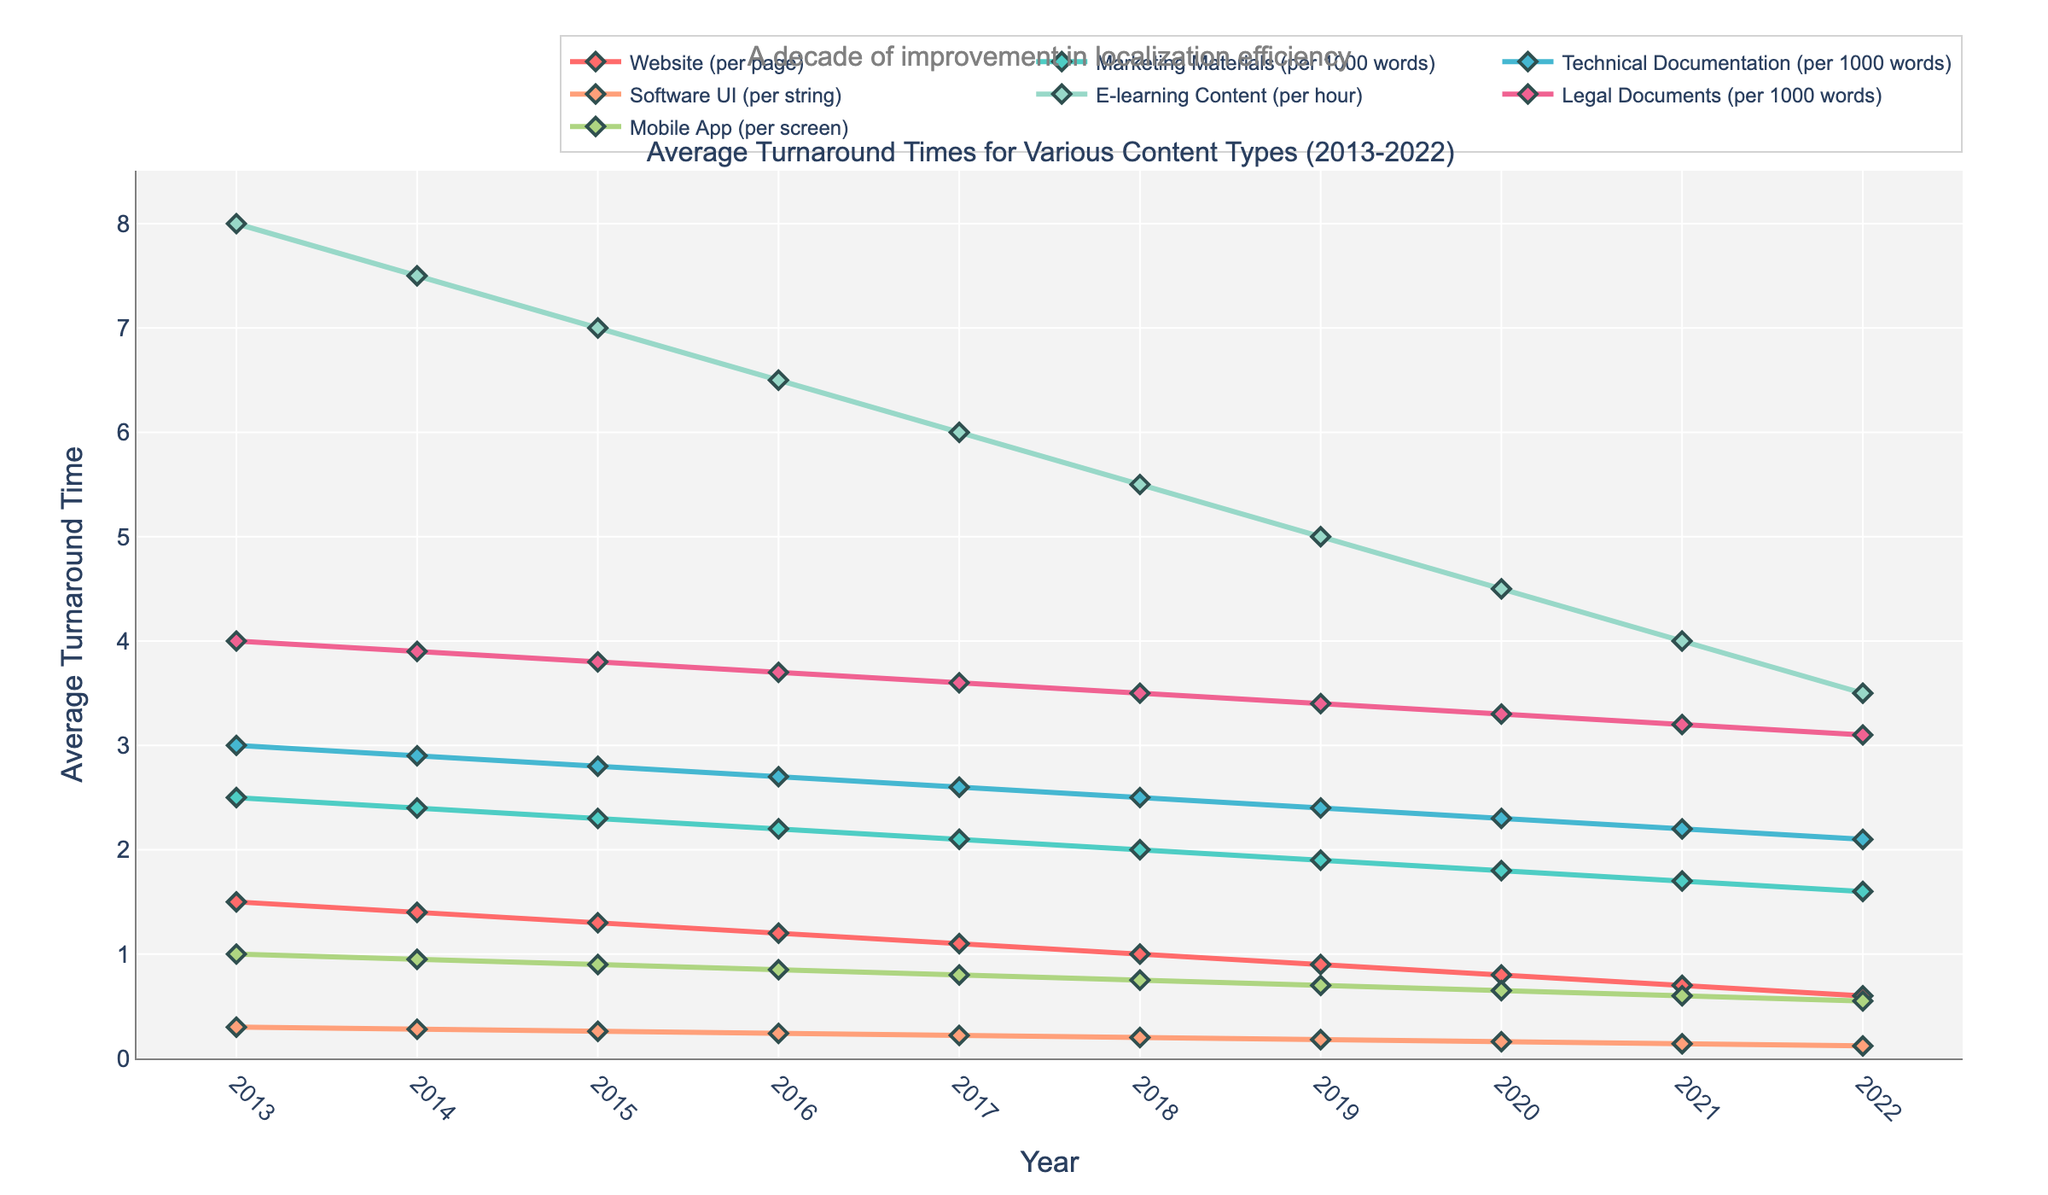What's the average turnaround time for Marketing Materials in 2015 and 2022? To find the average, add the turnaround times for 2015 and 2022 and divide by 2. For Marketing Materials, the times are 2.3 in 2015 and 1.6 in 2022. Sum them to get 3.9 and then divide by 2, which equals 1.95.
Answer: 1.95 Which content type had the greatest decrease in turnaround time from 2013 to 2022? Calculate the decrease for each content type by subtracting the 2022 value from the 2013 value. E-learning Content decreased from 8.0 to 3.5, which is 4.5. This is the largest decrease among all content types.
Answer: E-learning Content Which content type had the shortest turnaround time in 2020? Look at the plot and identify the shortest line above the x-axis in the year 2020. The Software UI had the shortest turnaround time in 2020 with a value of 0.16.
Answer: Software UI Compare the turnaround times for Website content and Mobile App content in 2019. Which one was lower? In 2019, the Website content time was 0.9 and the Mobile App content time was 0.7. Since 0.7 is less than 0.9, Mobile App content had a lower turnaround time.
Answer: Mobile App content What is the trend in turnaround times for Technical Documentation between 2013 and 2022? Evaluate the overall direction of the line for Technical Documentation from 2013 to 2022. It consistently decreases from 3.0 to 2.1, showing a declining trend.
Answer: Declining How many content types had turnaround times less than 1 in 2022? Note the values for each content type in 2022. Website (0.6), Software UI (0.12), Mobile App (0.55) are all less than 1. Therefore, three content types had turnaround times less than 1.
Answer: 3 Which year had the most significant decrease in turnaround times for Marketing Materials compared to the previous year? Examine the differences year by year for Marketing Materials. The largest annual decrease occurs from 2017 (2.1) to 2018 (2.0), which is 0.1.
Answer: 2017 to 2018 Which content type's turnaround time in 2022 is closest to the 2013 turnaround time of Software UI? The 2013 turnaround time of Software UI is 0.3. Comparing the 2022 times, the closest value is 0.6 for Websites.
Answer: Website Identify the content type that had the smallest overall decrease in turnaround time from 2013 to 2022. Calculate the difference for each content type. Legal Documents decreased from 4.0 to 3.1, which is a reduction of 0.9, the smallest among all the content types.
Answer: Legal Documents 